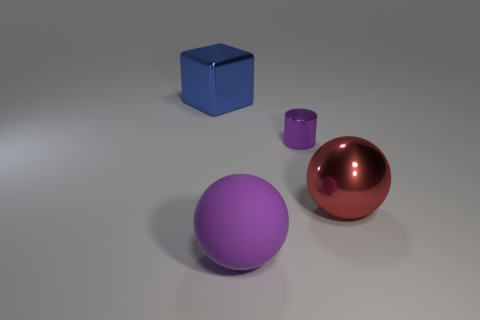Add 1 brown metal blocks. How many objects exist? 5 Subtract all blocks. How many objects are left? 3 Subtract 1 purple cylinders. How many objects are left? 3 Subtract all large brown shiny balls. Subtract all large blue metal things. How many objects are left? 3 Add 4 big purple rubber objects. How many big purple rubber objects are left? 5 Add 1 big red matte blocks. How many big red matte blocks exist? 1 